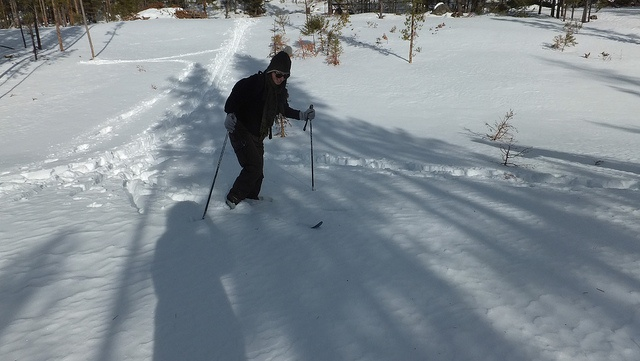Describe the objects in this image and their specific colors. I can see people in black, gray, and darkgray tones and skis in black, blue, and darkblue tones in this image. 